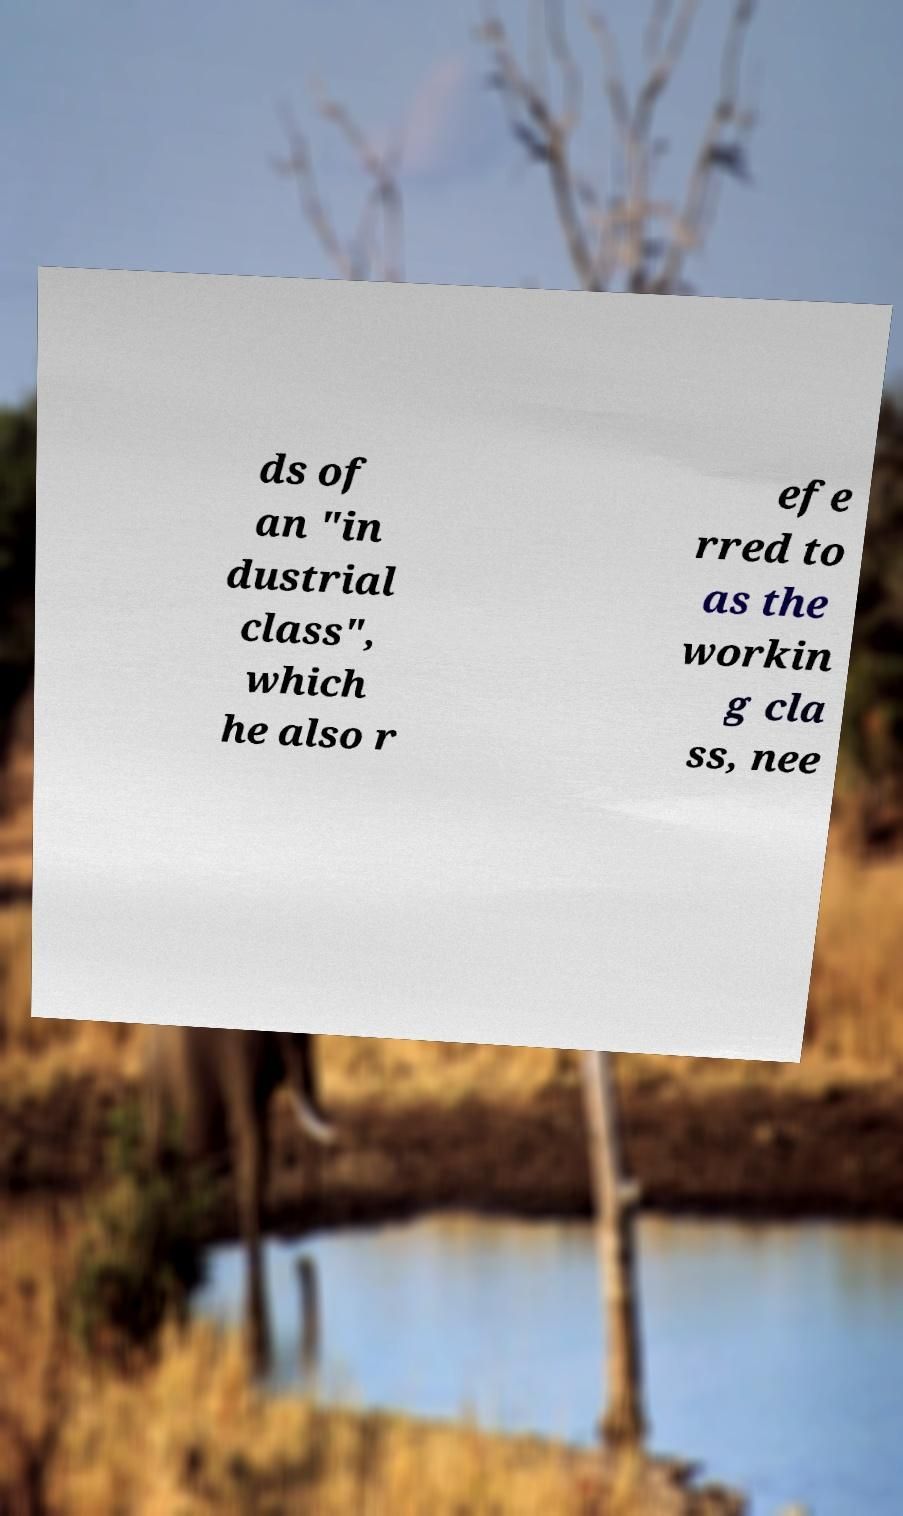Please read and relay the text visible in this image. What does it say? ds of an "in dustrial class", which he also r efe rred to as the workin g cla ss, nee 